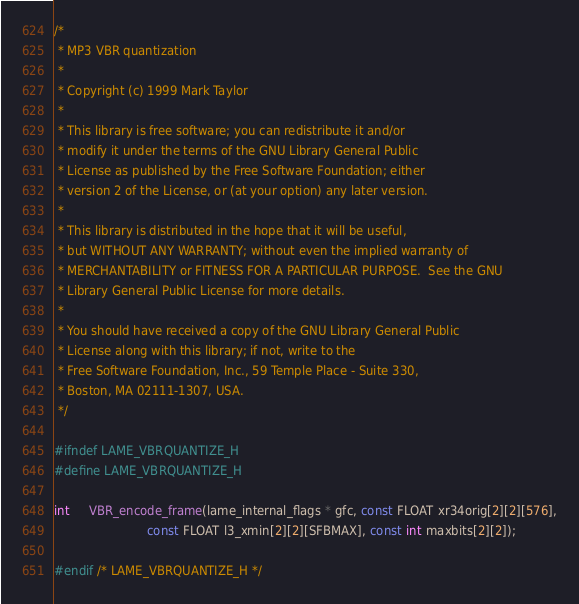<code> <loc_0><loc_0><loc_500><loc_500><_C_>/*
 * MP3 VBR quantization
 *
 * Copyright (c) 1999 Mark Taylor
 *
 * This library is free software; you can redistribute it and/or
 * modify it under the terms of the GNU Library General Public
 * License as published by the Free Software Foundation; either
 * version 2 of the License, or (at your option) any later version.
 *
 * This library is distributed in the hope that it will be useful,
 * but WITHOUT ANY WARRANTY; without even the implied warranty of
 * MERCHANTABILITY or FITNESS FOR A PARTICULAR PURPOSE.	 See the GNU
 * Library General Public License for more details.
 *
 * You should have received a copy of the GNU Library General Public
 * License along with this library; if not, write to the
 * Free Software Foundation, Inc., 59 Temple Place - Suite 330,
 * Boston, MA 02111-1307, USA.
 */

#ifndef LAME_VBRQUANTIZE_H
#define LAME_VBRQUANTIZE_H

int     VBR_encode_frame(lame_internal_flags * gfc, const FLOAT xr34orig[2][2][576],
                         const FLOAT l3_xmin[2][2][SFBMAX], const int maxbits[2][2]);

#endif /* LAME_VBRQUANTIZE_H */
</code> 